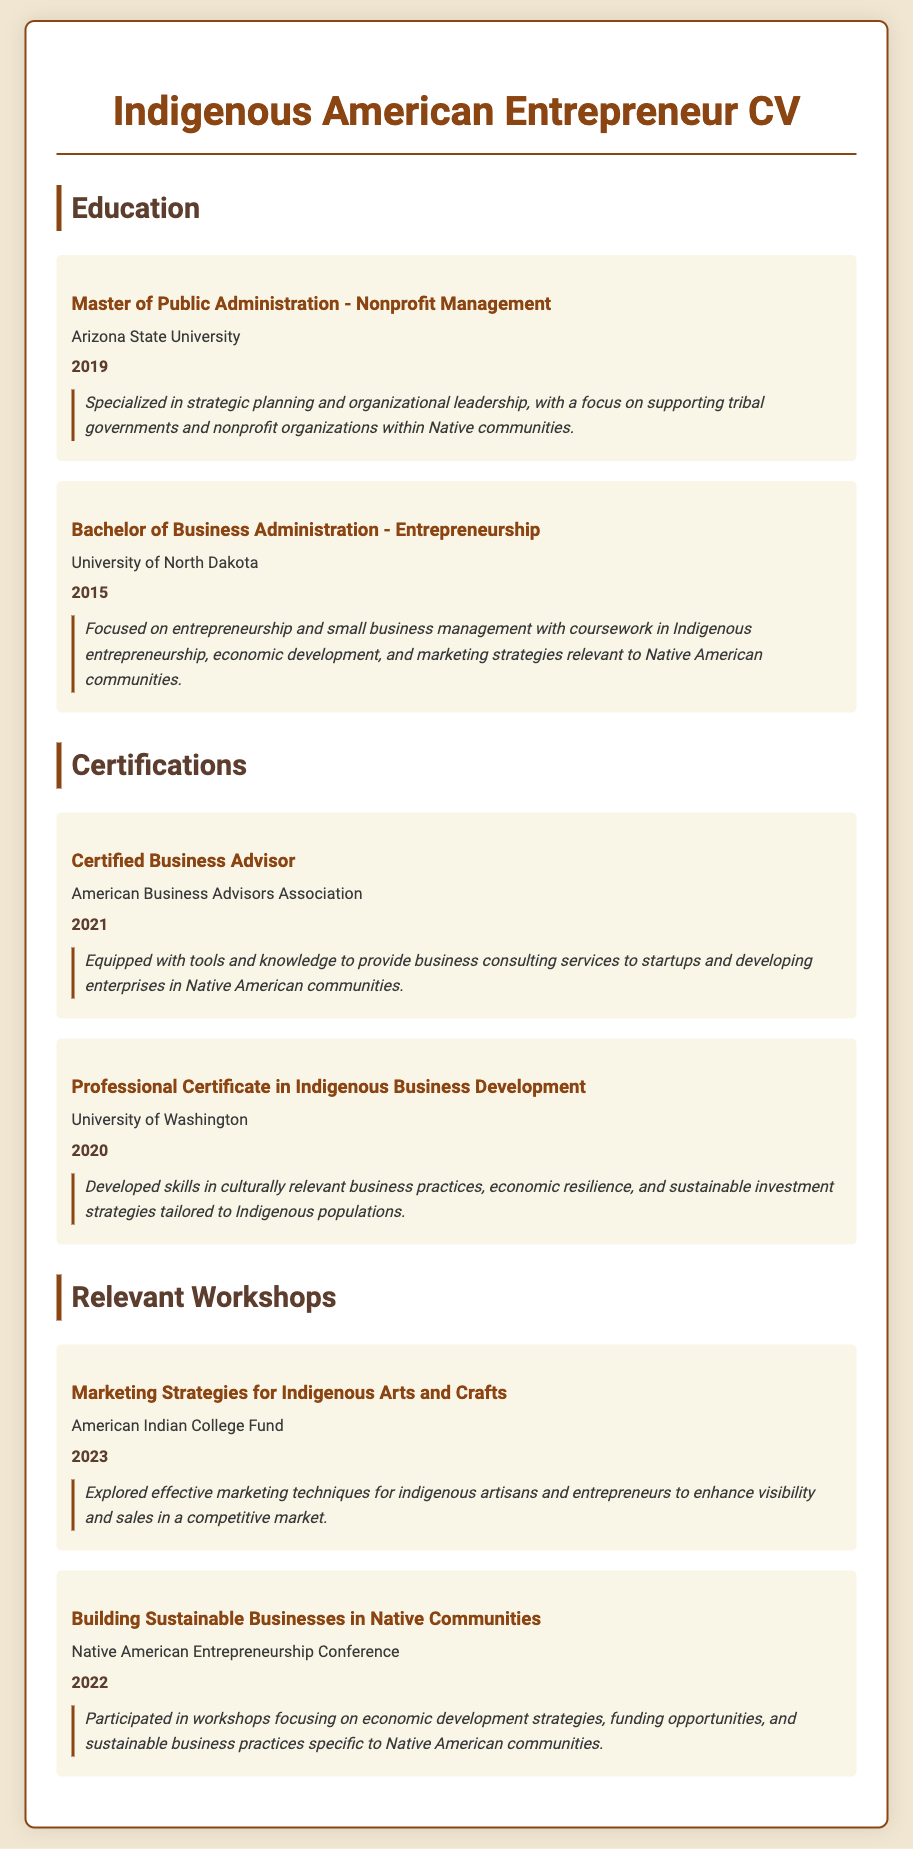What is the degree obtained in 2019? The degree obtained in 2019 is a Master of Public Administration - Nonprofit Management from Arizona State University.
Answer: Master of Public Administration - Nonprofit Management What is the name of the university where the Bachelor of Business Administration was earned? The Bachelor of Business Administration was earned from the University of North Dakota.
Answer: University of North Dakota What certification was obtained in 2021? The certification obtained in 2021 is Certified Business Advisor.
Answer: Certified Business Advisor Which workshop took place in 2023? The workshop that took place in 2023 is Marketing Strategies for Indigenous Arts and Crafts.
Answer: Marketing Strategies for Indigenous Arts and Crafts What was the focus of the Bachelor of Business Administration? The Bachelor of Business Administration focused on entrepreneurship and small business management.
Answer: Entrepreneurship and small business management What is the professional certificate obtained from the University of Washington? The professional certificate obtained from the University of Washington is in Indigenous Business Development.
Answer: Professional Certificate in Indigenous Business Development How many relevant workshops are listed in the document? There are two relevant workshops listed in the document.
Answer: Two What year was the workshop on Building Sustainable Businesses in Native Communities held? The workshop on Building Sustainable Businesses in Native Communities was held in 2022.
Answer: 2022 What type of business practices was emphasized in the Indigenous Business Development certification? The Indigenous Business Development certification emphasized culturally relevant business practices.
Answer: Culturally relevant business practices 